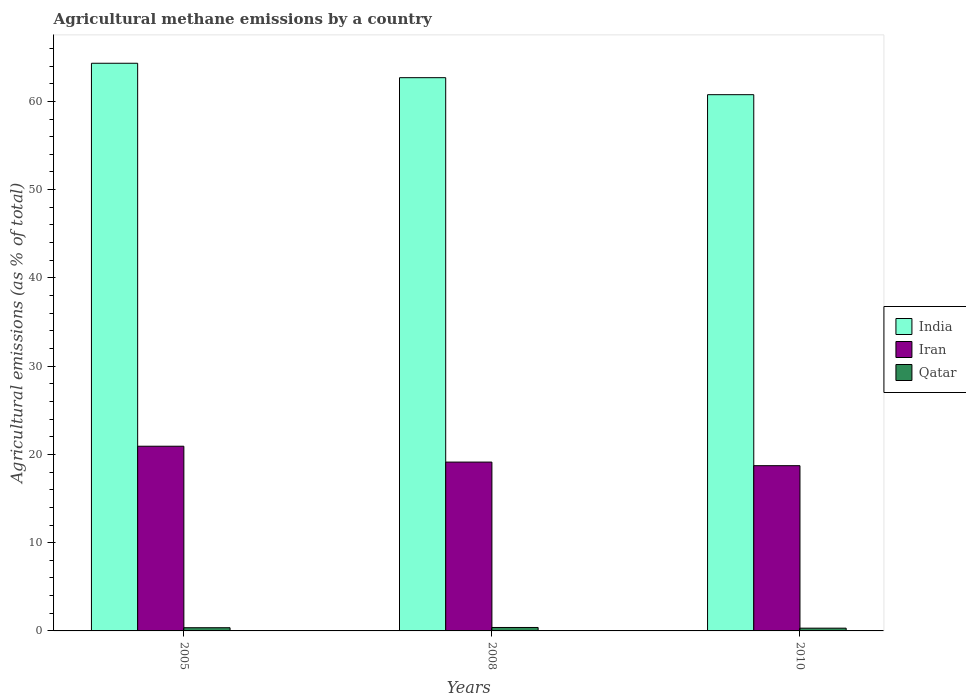How many different coloured bars are there?
Your answer should be compact. 3. Are the number of bars per tick equal to the number of legend labels?
Offer a terse response. Yes. What is the amount of agricultural methane emitted in Iran in 2005?
Provide a succinct answer. 20.93. Across all years, what is the maximum amount of agricultural methane emitted in Iran?
Keep it short and to the point. 20.93. Across all years, what is the minimum amount of agricultural methane emitted in Iran?
Ensure brevity in your answer.  18.72. What is the total amount of agricultural methane emitted in Qatar in the graph?
Your response must be concise. 1.06. What is the difference between the amount of agricultural methane emitted in Iran in 2005 and that in 2008?
Your answer should be compact. 1.8. What is the difference between the amount of agricultural methane emitted in Iran in 2008 and the amount of agricultural methane emitted in Qatar in 2005?
Ensure brevity in your answer.  18.77. What is the average amount of agricultural methane emitted in India per year?
Keep it short and to the point. 62.59. In the year 2005, what is the difference between the amount of agricultural methane emitted in Iran and amount of agricultural methane emitted in Qatar?
Provide a succinct answer. 20.56. What is the ratio of the amount of agricultural methane emitted in India in 2005 to that in 2008?
Your answer should be compact. 1.03. Is the amount of agricultural methane emitted in India in 2005 less than that in 2008?
Offer a terse response. No. Is the difference between the amount of agricultural methane emitted in Iran in 2005 and 2008 greater than the difference between the amount of agricultural methane emitted in Qatar in 2005 and 2008?
Provide a short and direct response. Yes. What is the difference between the highest and the second highest amount of agricultural methane emitted in India?
Your answer should be very brief. 1.63. What is the difference between the highest and the lowest amount of agricultural methane emitted in Iran?
Your answer should be very brief. 2.2. What does the 3rd bar from the left in 2010 represents?
Provide a short and direct response. Qatar. Are all the bars in the graph horizontal?
Your response must be concise. No. Does the graph contain grids?
Offer a terse response. No. How many legend labels are there?
Offer a very short reply. 3. What is the title of the graph?
Offer a very short reply. Agricultural methane emissions by a country. Does "Mongolia" appear as one of the legend labels in the graph?
Give a very brief answer. No. What is the label or title of the Y-axis?
Give a very brief answer. Agricultural emissions (as % of total). What is the Agricultural emissions (as % of total) of India in 2005?
Your answer should be very brief. 64.32. What is the Agricultural emissions (as % of total) in Iran in 2005?
Ensure brevity in your answer.  20.93. What is the Agricultural emissions (as % of total) of Qatar in 2005?
Give a very brief answer. 0.36. What is the Agricultural emissions (as % of total) in India in 2008?
Make the answer very short. 62.68. What is the Agricultural emissions (as % of total) in Iran in 2008?
Provide a succinct answer. 19.13. What is the Agricultural emissions (as % of total) in Qatar in 2008?
Offer a terse response. 0.39. What is the Agricultural emissions (as % of total) in India in 2010?
Your answer should be very brief. 60.76. What is the Agricultural emissions (as % of total) of Iran in 2010?
Give a very brief answer. 18.72. What is the Agricultural emissions (as % of total) in Qatar in 2010?
Keep it short and to the point. 0.31. Across all years, what is the maximum Agricultural emissions (as % of total) in India?
Make the answer very short. 64.32. Across all years, what is the maximum Agricultural emissions (as % of total) of Iran?
Ensure brevity in your answer.  20.93. Across all years, what is the maximum Agricultural emissions (as % of total) in Qatar?
Ensure brevity in your answer.  0.39. Across all years, what is the minimum Agricultural emissions (as % of total) of India?
Provide a succinct answer. 60.76. Across all years, what is the minimum Agricultural emissions (as % of total) of Iran?
Give a very brief answer. 18.72. Across all years, what is the minimum Agricultural emissions (as % of total) of Qatar?
Give a very brief answer. 0.31. What is the total Agricultural emissions (as % of total) of India in the graph?
Your answer should be compact. 187.76. What is the total Agricultural emissions (as % of total) in Iran in the graph?
Give a very brief answer. 58.78. What is the total Agricultural emissions (as % of total) in Qatar in the graph?
Your answer should be compact. 1.06. What is the difference between the Agricultural emissions (as % of total) in India in 2005 and that in 2008?
Ensure brevity in your answer.  1.63. What is the difference between the Agricultural emissions (as % of total) in Iran in 2005 and that in 2008?
Your answer should be compact. 1.8. What is the difference between the Agricultural emissions (as % of total) in Qatar in 2005 and that in 2008?
Your answer should be very brief. -0.03. What is the difference between the Agricultural emissions (as % of total) of India in 2005 and that in 2010?
Give a very brief answer. 3.56. What is the difference between the Agricultural emissions (as % of total) in Iran in 2005 and that in 2010?
Keep it short and to the point. 2.2. What is the difference between the Agricultural emissions (as % of total) of Qatar in 2005 and that in 2010?
Ensure brevity in your answer.  0.05. What is the difference between the Agricultural emissions (as % of total) of India in 2008 and that in 2010?
Make the answer very short. 1.93. What is the difference between the Agricultural emissions (as % of total) in Iran in 2008 and that in 2010?
Give a very brief answer. 0.41. What is the difference between the Agricultural emissions (as % of total) in Qatar in 2008 and that in 2010?
Provide a succinct answer. 0.08. What is the difference between the Agricultural emissions (as % of total) in India in 2005 and the Agricultural emissions (as % of total) in Iran in 2008?
Keep it short and to the point. 45.19. What is the difference between the Agricultural emissions (as % of total) of India in 2005 and the Agricultural emissions (as % of total) of Qatar in 2008?
Your answer should be very brief. 63.93. What is the difference between the Agricultural emissions (as % of total) in Iran in 2005 and the Agricultural emissions (as % of total) in Qatar in 2008?
Ensure brevity in your answer.  20.54. What is the difference between the Agricultural emissions (as % of total) in India in 2005 and the Agricultural emissions (as % of total) in Iran in 2010?
Make the answer very short. 45.59. What is the difference between the Agricultural emissions (as % of total) in India in 2005 and the Agricultural emissions (as % of total) in Qatar in 2010?
Keep it short and to the point. 64. What is the difference between the Agricultural emissions (as % of total) of Iran in 2005 and the Agricultural emissions (as % of total) of Qatar in 2010?
Provide a short and direct response. 20.61. What is the difference between the Agricultural emissions (as % of total) of India in 2008 and the Agricultural emissions (as % of total) of Iran in 2010?
Ensure brevity in your answer.  43.96. What is the difference between the Agricultural emissions (as % of total) in India in 2008 and the Agricultural emissions (as % of total) in Qatar in 2010?
Your answer should be compact. 62.37. What is the difference between the Agricultural emissions (as % of total) in Iran in 2008 and the Agricultural emissions (as % of total) in Qatar in 2010?
Your response must be concise. 18.82. What is the average Agricultural emissions (as % of total) in India per year?
Ensure brevity in your answer.  62.59. What is the average Agricultural emissions (as % of total) in Iran per year?
Give a very brief answer. 19.59. What is the average Agricultural emissions (as % of total) of Qatar per year?
Offer a very short reply. 0.35. In the year 2005, what is the difference between the Agricultural emissions (as % of total) in India and Agricultural emissions (as % of total) in Iran?
Offer a very short reply. 43.39. In the year 2005, what is the difference between the Agricultural emissions (as % of total) in India and Agricultural emissions (as % of total) in Qatar?
Your answer should be very brief. 63.95. In the year 2005, what is the difference between the Agricultural emissions (as % of total) of Iran and Agricultural emissions (as % of total) of Qatar?
Your response must be concise. 20.56. In the year 2008, what is the difference between the Agricultural emissions (as % of total) of India and Agricultural emissions (as % of total) of Iran?
Keep it short and to the point. 43.55. In the year 2008, what is the difference between the Agricultural emissions (as % of total) of India and Agricultural emissions (as % of total) of Qatar?
Offer a very short reply. 62.29. In the year 2008, what is the difference between the Agricultural emissions (as % of total) of Iran and Agricultural emissions (as % of total) of Qatar?
Provide a succinct answer. 18.74. In the year 2010, what is the difference between the Agricultural emissions (as % of total) in India and Agricultural emissions (as % of total) in Iran?
Offer a terse response. 42.03. In the year 2010, what is the difference between the Agricultural emissions (as % of total) in India and Agricultural emissions (as % of total) in Qatar?
Provide a short and direct response. 60.44. In the year 2010, what is the difference between the Agricultural emissions (as % of total) of Iran and Agricultural emissions (as % of total) of Qatar?
Provide a succinct answer. 18.41. What is the ratio of the Agricultural emissions (as % of total) in India in 2005 to that in 2008?
Your answer should be compact. 1.03. What is the ratio of the Agricultural emissions (as % of total) in Iran in 2005 to that in 2008?
Your answer should be very brief. 1.09. What is the ratio of the Agricultural emissions (as % of total) of Qatar in 2005 to that in 2008?
Offer a terse response. 0.93. What is the ratio of the Agricultural emissions (as % of total) of India in 2005 to that in 2010?
Your response must be concise. 1.06. What is the ratio of the Agricultural emissions (as % of total) of Iran in 2005 to that in 2010?
Keep it short and to the point. 1.12. What is the ratio of the Agricultural emissions (as % of total) of Qatar in 2005 to that in 2010?
Offer a terse response. 1.16. What is the ratio of the Agricultural emissions (as % of total) in India in 2008 to that in 2010?
Keep it short and to the point. 1.03. What is the ratio of the Agricultural emissions (as % of total) in Iran in 2008 to that in 2010?
Your answer should be very brief. 1.02. What is the ratio of the Agricultural emissions (as % of total) of Qatar in 2008 to that in 2010?
Offer a terse response. 1.25. What is the difference between the highest and the second highest Agricultural emissions (as % of total) in India?
Offer a very short reply. 1.63. What is the difference between the highest and the second highest Agricultural emissions (as % of total) in Iran?
Your response must be concise. 1.8. What is the difference between the highest and the second highest Agricultural emissions (as % of total) in Qatar?
Give a very brief answer. 0.03. What is the difference between the highest and the lowest Agricultural emissions (as % of total) in India?
Provide a short and direct response. 3.56. What is the difference between the highest and the lowest Agricultural emissions (as % of total) in Iran?
Make the answer very short. 2.2. What is the difference between the highest and the lowest Agricultural emissions (as % of total) in Qatar?
Your answer should be compact. 0.08. 